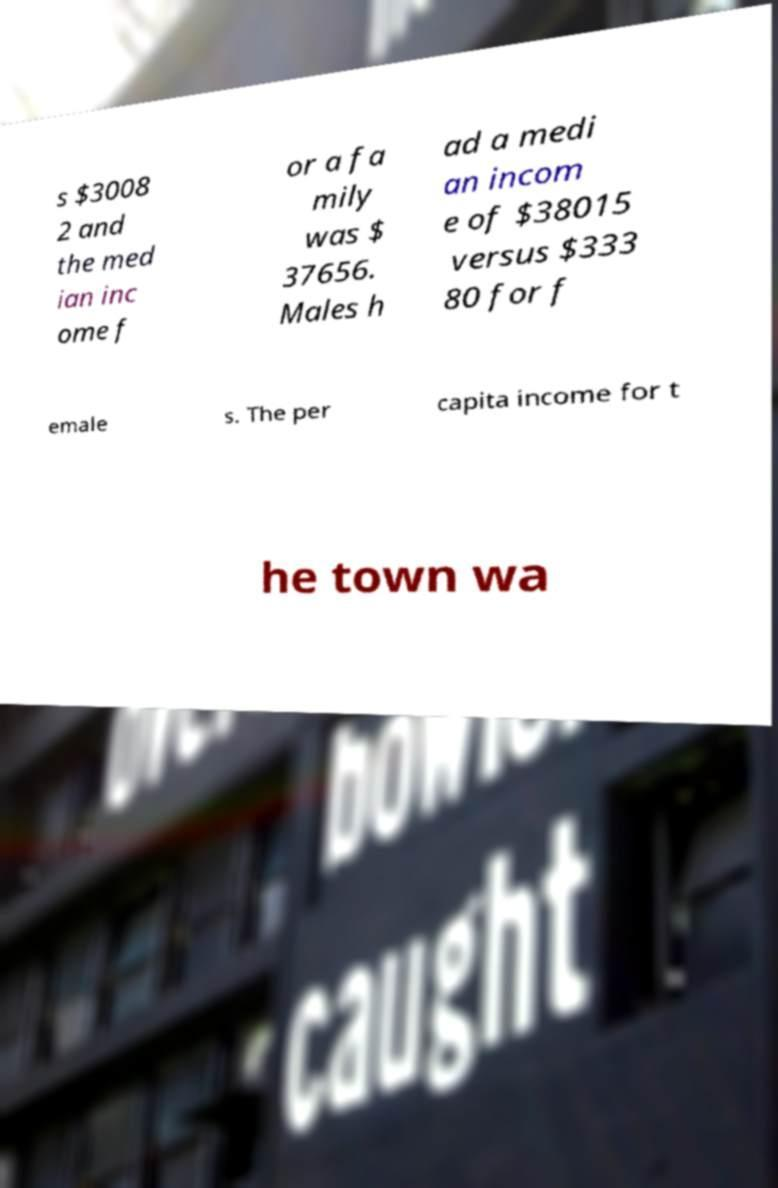Could you extract and type out the text from this image? s $3008 2 and the med ian inc ome f or a fa mily was $ 37656. Males h ad a medi an incom e of $38015 versus $333 80 for f emale s. The per capita income for t he town wa 